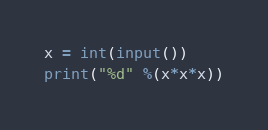<code> <loc_0><loc_0><loc_500><loc_500><_Python_>x = int(input())
print("%d" %(x*x*x))
</code> 